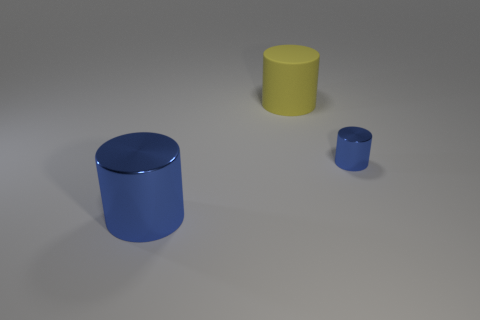Add 2 rubber cylinders. How many objects exist? 5 Subtract all small shiny cylinders. Subtract all gray shiny things. How many objects are left? 2 Add 2 small blue metallic cylinders. How many small blue metallic cylinders are left? 3 Add 1 large cylinders. How many large cylinders exist? 3 Subtract 0 gray cylinders. How many objects are left? 3 